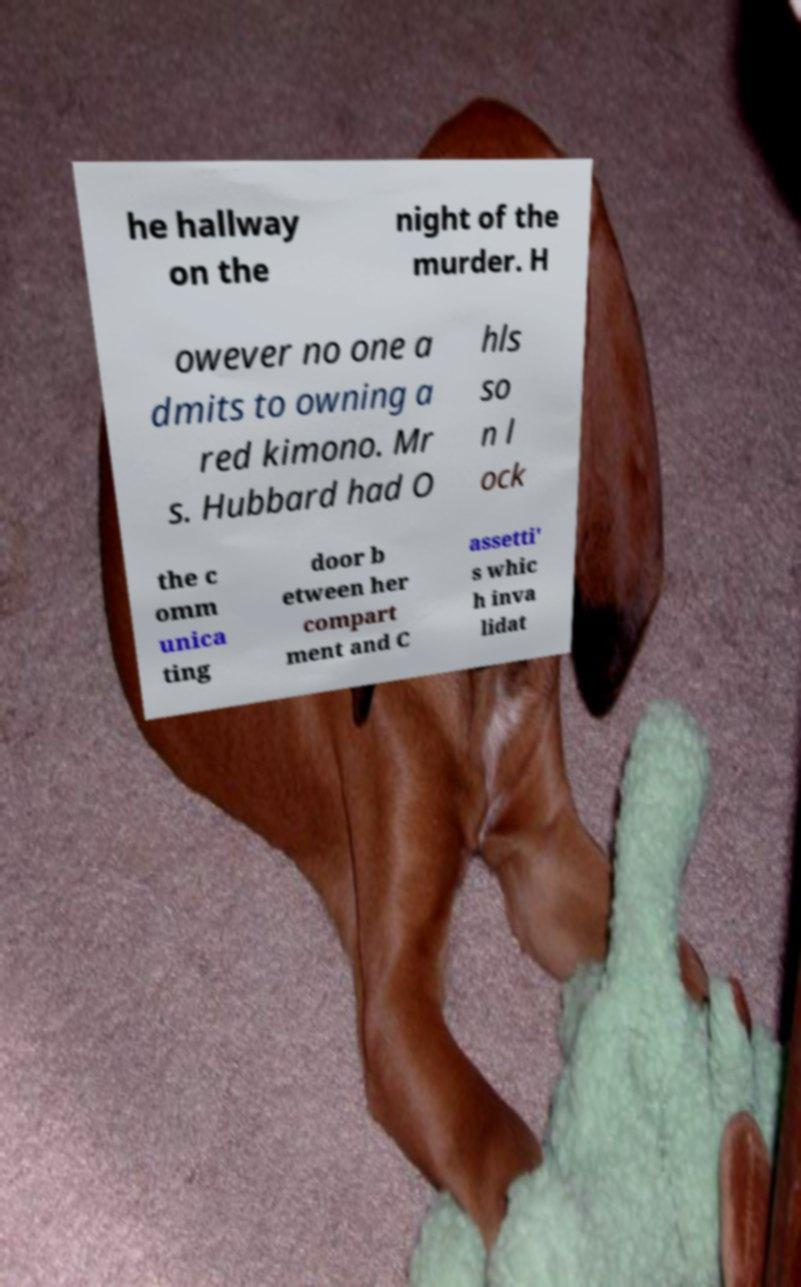Please read and relay the text visible in this image. What does it say? he hallway on the night of the murder. H owever no one a dmits to owning a red kimono. Mr s. Hubbard had O hls so n l ock the c omm unica ting door b etween her compart ment and C assetti' s whic h inva lidat 